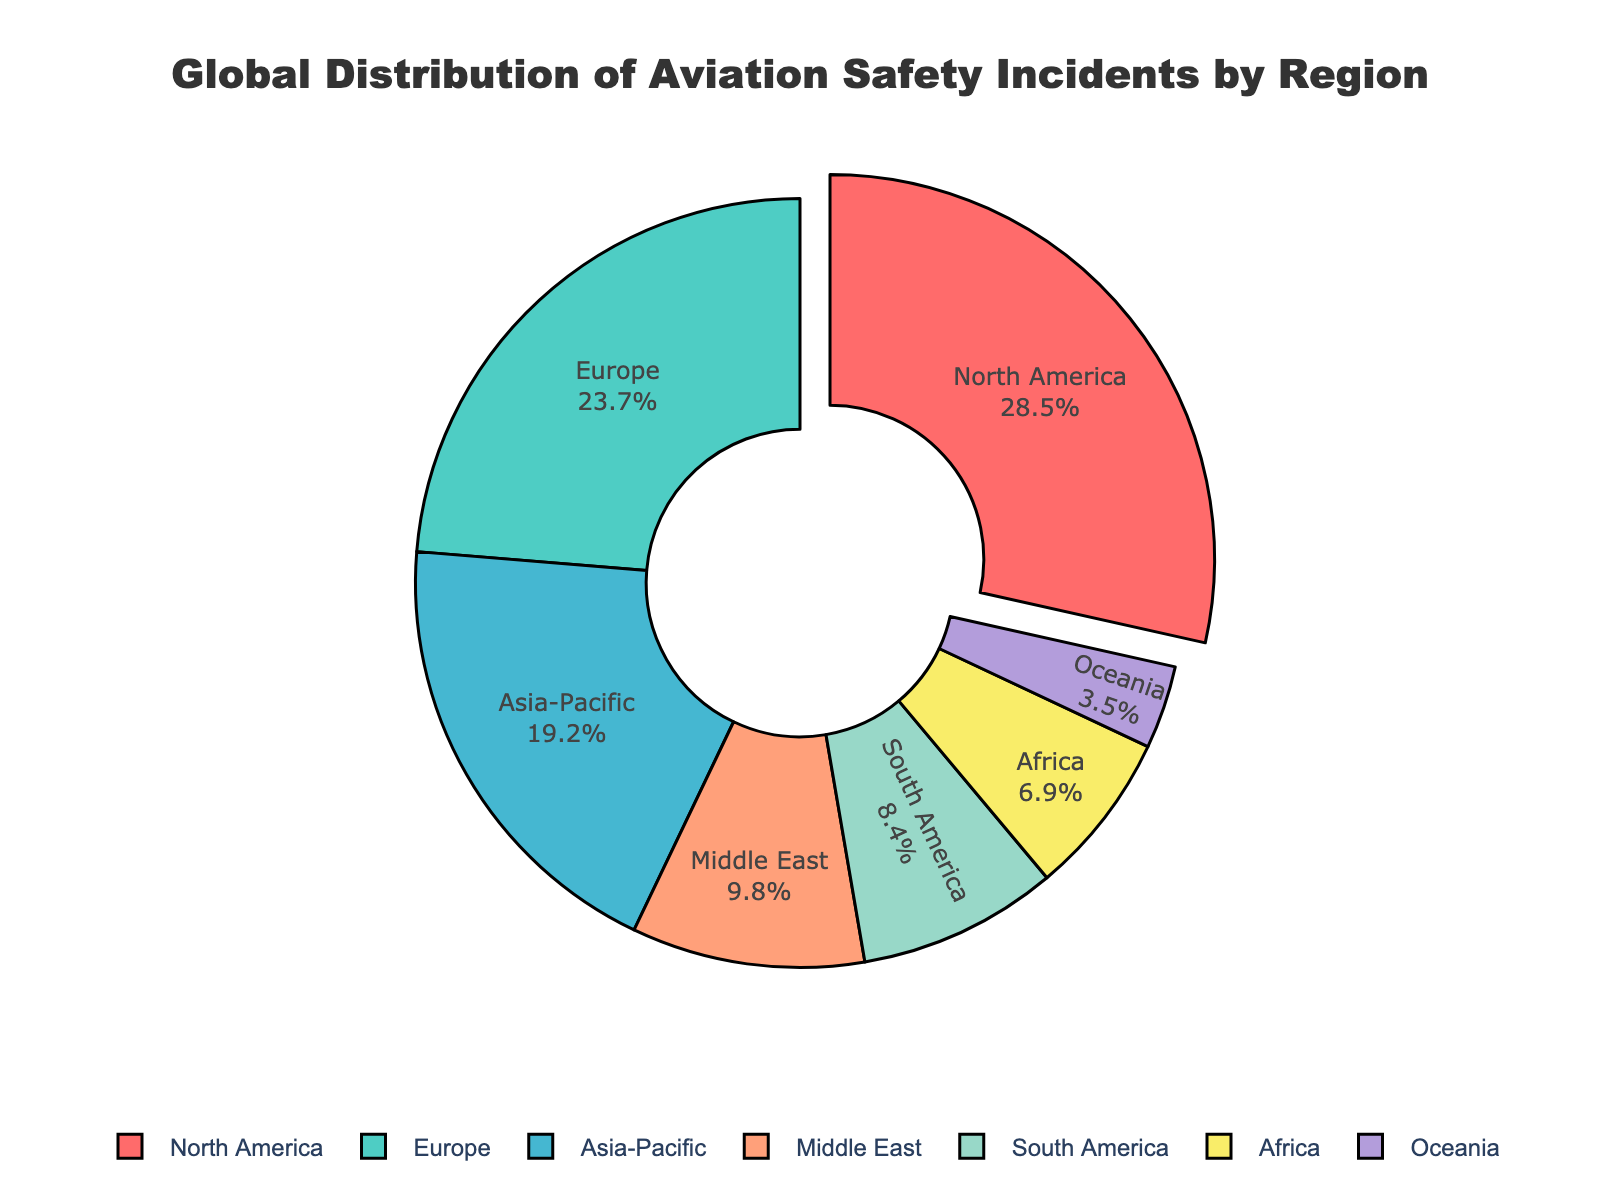what region has the highest percentage of aviation safety incidents? North America has the highest percentage because the segment is visually emphasized by being "pulled out" from the pie chart and it is labeled with 28.5%.
Answer: North America Which region has the second-highest percentage of aviation safety incidents? Europe has the second-highest percentage because it is labeled with 23.7%, which is the second-largest percentage after North America.
Answer: Europe How much more is the percentage of incidents in North America compared to Asia-Pacific? The percentage of incidents in North America is 28.5% and in Asia-Pacific is 19.2%. The difference is calculated as 28.5% - 19.2% = 9.3%.
Answer: 9.3% What is the combined percentage of incidents for Europe and the Middle East? The percentage of incidents for Europe is 23.7% and for the Middle East is 9.8%. The combined percentage is 23.7% + 9.8% = 33.5%.
Answer: 33.5% Which region has the smallest percentage of aviation safety incidents? Oceania has the smallest percentage because it is labeled with 3.5%, which is the lowest percentage on the chart.
Answer: Oceania What percentage of incidents do Africa and Oceania contribute together? The percentage of incidents for Africa is 6.9% and for Oceania is 3.5%. Together, they contribute 6.9% + 3.5% = 10.4%.
Answer: 10.4% Are there any regions with a percentage of incidents greater than 20% but less than 30%? Yes, North America and Europe fall within this range. North America has 28.5% and Europe has 23.7%.
Answer: Yes How does the percentage of incidents in South America compare to that in Africa? South America has 8.4% and Africa has 6.9%. South America has a higher percentage of incidents compared to Africa by 8.4% - 6.9% = 1.5%.
Answer: South America has 1.5% more What is the average percentage of incidents for the regions listed? To find the average, sum all percentages: 28.5 + 23.7 + 19.2 + 9.8 + 8.4 + 6.9 + 3.5 = 100%. The average is 100/7 ≈ 14.29%.
Answer: 14.29% What regions account for less than 10% of aviation safety incidents individually? The regions that account for less than 10% of incidents individually are the Middle East (9.8%), South America (8.4%), Africa (6.9%), and Oceania (3.5%).
Answer: Middle East, South America, Africa, and Oceania 